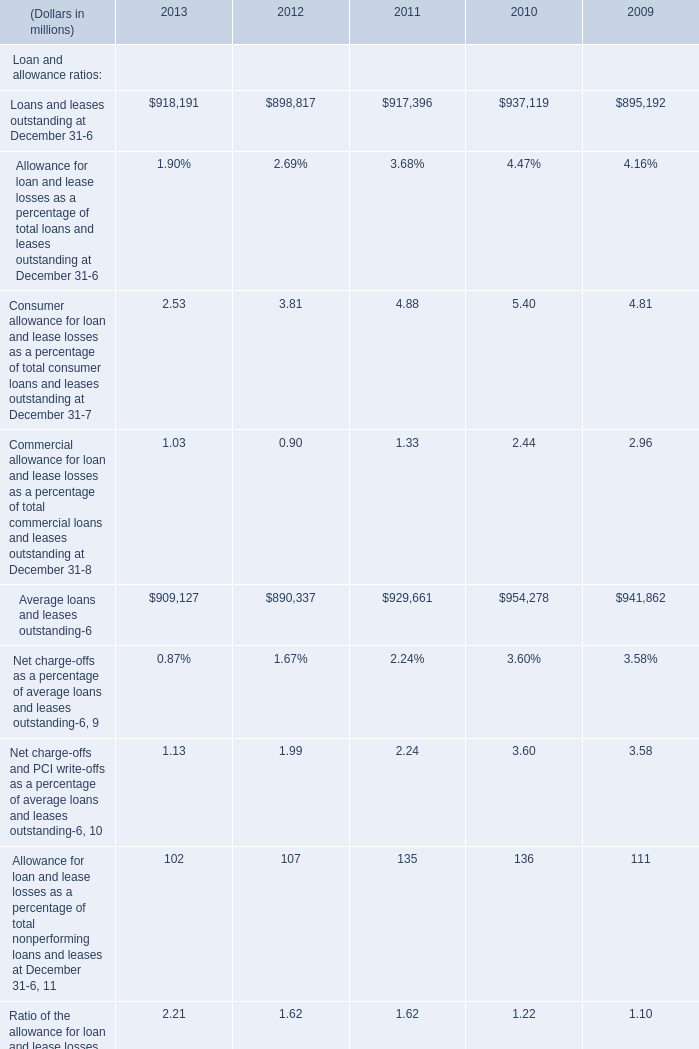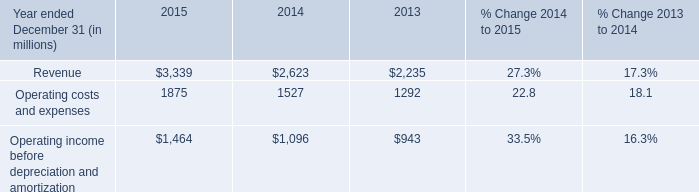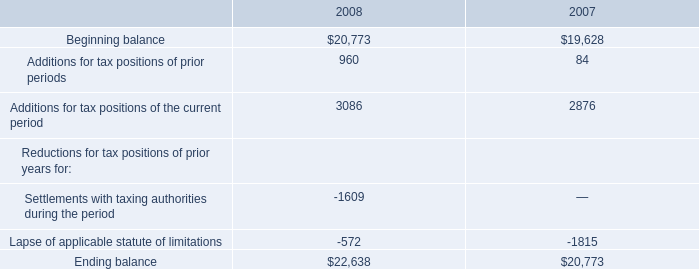What is the total amount of Additions for tax positions of the current period of 2008, and Loans and leases outstanding at December 31 of 2009 ? 
Computations: (3086.0 + 895192.0)
Answer: 898278.0. What is the average amount of Loans and leases outstanding at December 31 of 2009, and Operating income before depreciation and amortization of 2015 ? 
Computations: ((895192.0 + 1464.0) / 2)
Answer: 448328.0. 